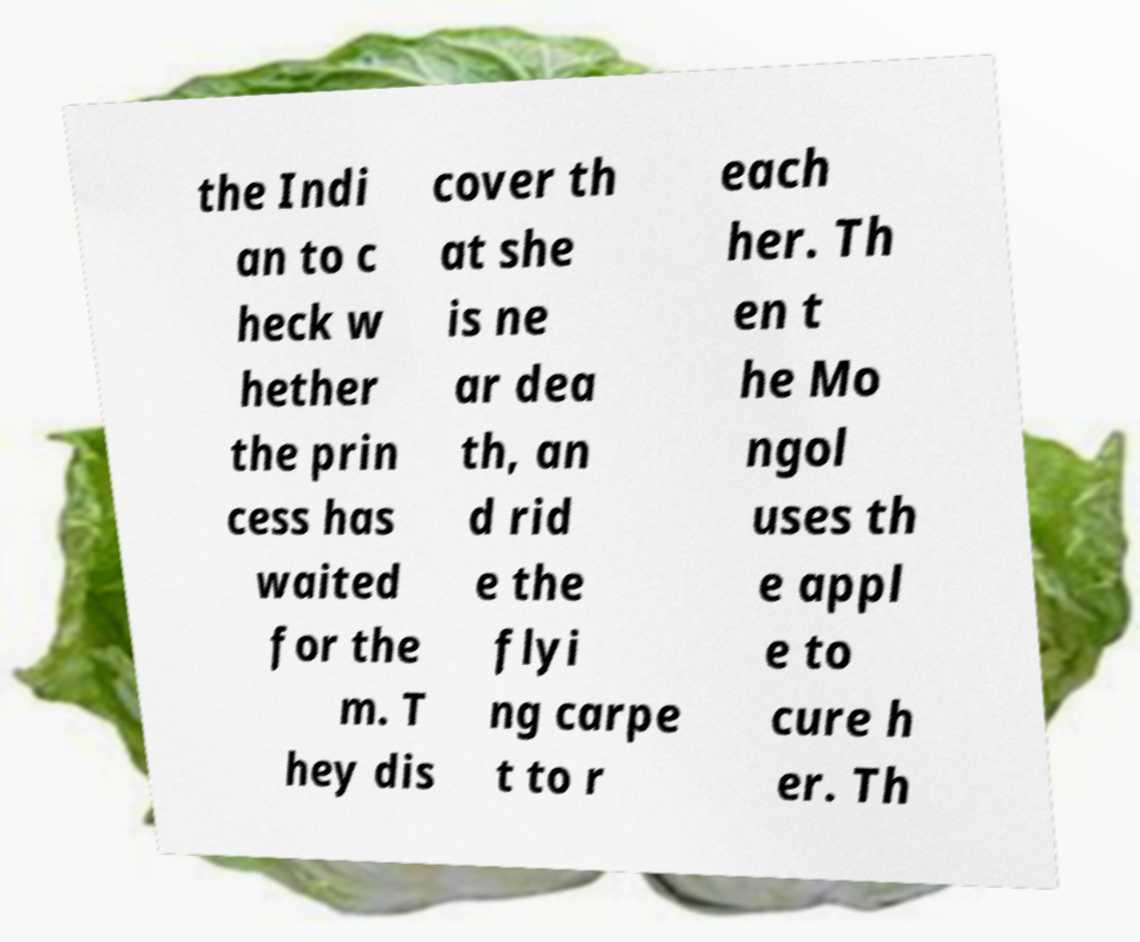For documentation purposes, I need the text within this image transcribed. Could you provide that? the Indi an to c heck w hether the prin cess has waited for the m. T hey dis cover th at she is ne ar dea th, an d rid e the flyi ng carpe t to r each her. Th en t he Mo ngol uses th e appl e to cure h er. Th 